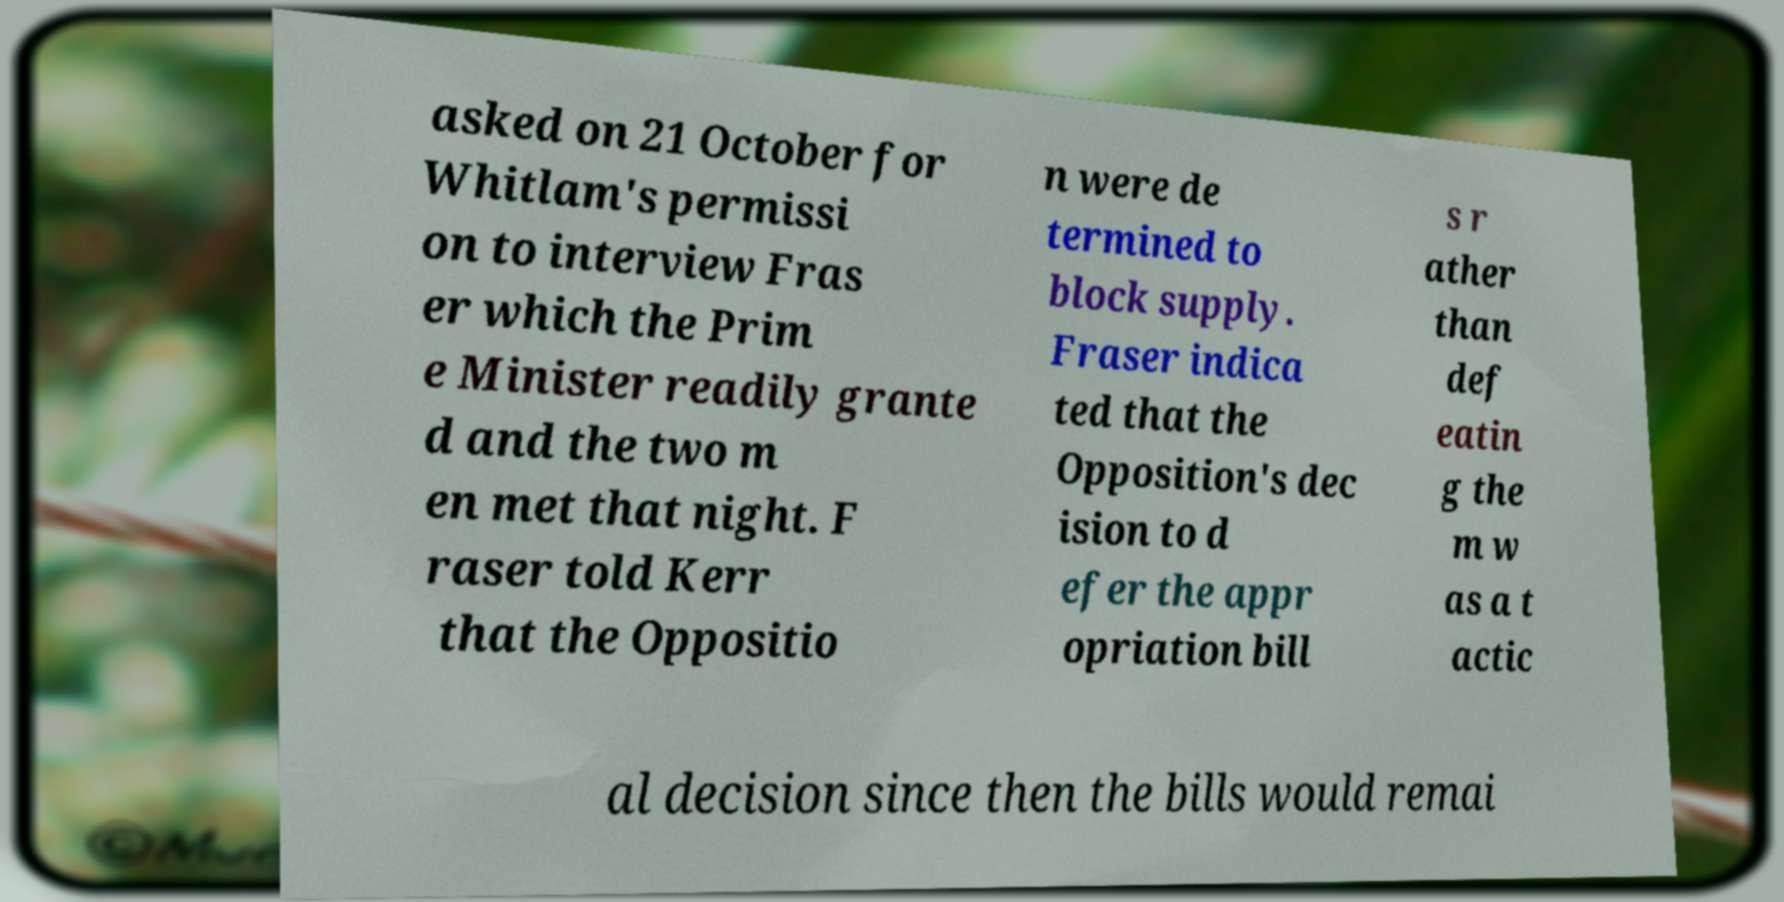Could you extract and type out the text from this image? asked on 21 October for Whitlam's permissi on to interview Fras er which the Prim e Minister readily grante d and the two m en met that night. F raser told Kerr that the Oppositio n were de termined to block supply. Fraser indica ted that the Opposition's dec ision to d efer the appr opriation bill s r ather than def eatin g the m w as a t actic al decision since then the bills would remai 